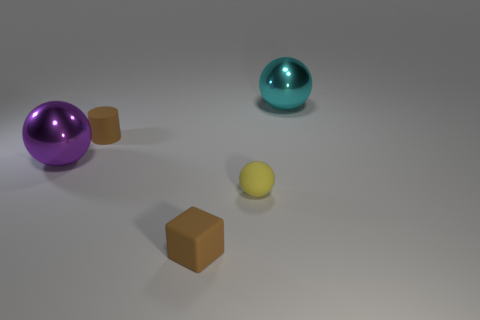Is the tiny matte cylinder the same color as the tiny matte cube?
Give a very brief answer. Yes. What is the color of the rubber object that is in front of the tiny matte cylinder and left of the tiny yellow object?
Ensure brevity in your answer.  Brown. What number of other spheres have the same size as the purple sphere?
Keep it short and to the point. 1. What is the size of the object that is behind the large purple thing and left of the small matte ball?
Your response must be concise. Small. There is a large metallic object that is behind the object that is left of the matte cylinder; how many large shiny spheres are in front of it?
Ensure brevity in your answer.  1. Are there any small rubber objects that have the same color as the cylinder?
Your answer should be very brief. Yes. There is a ball that is the same size as the brown rubber block; what color is it?
Offer a very short reply. Yellow. What shape is the big metal thing on the right side of the large metal sphere on the left side of the object behind the brown matte cylinder?
Your response must be concise. Sphere. There is a large sphere on the right side of the rubber block; what number of metal spheres are left of it?
Ensure brevity in your answer.  1. There is a object that is on the right side of the tiny sphere; is it the same shape as the large shiny object left of the small brown rubber cylinder?
Make the answer very short. Yes. 